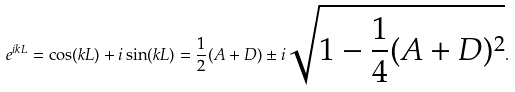Convert formula to latex. <formula><loc_0><loc_0><loc_500><loc_500>e ^ { i k L } = \cos ( k L ) + i \sin ( k L ) = \frac { 1 } { 2 } ( A + D ) \pm i \sqrt { 1 - \frac { 1 } { 4 } ( A + D ) ^ { 2 } } .</formula> 